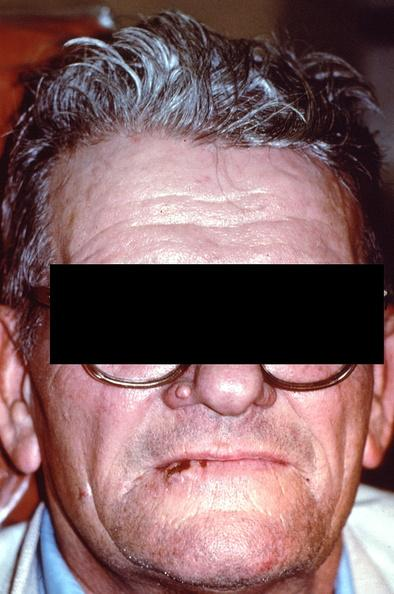does this image show squamous cell carcinoma, lip?
Answer the question using a single word or phrase. Yes 